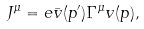Convert formula to latex. <formula><loc_0><loc_0><loc_500><loc_500>J ^ { \mu } = e \bar { v } ( p ^ { \prime } ) \Gamma ^ { \mu } v ( p ) ,</formula> 